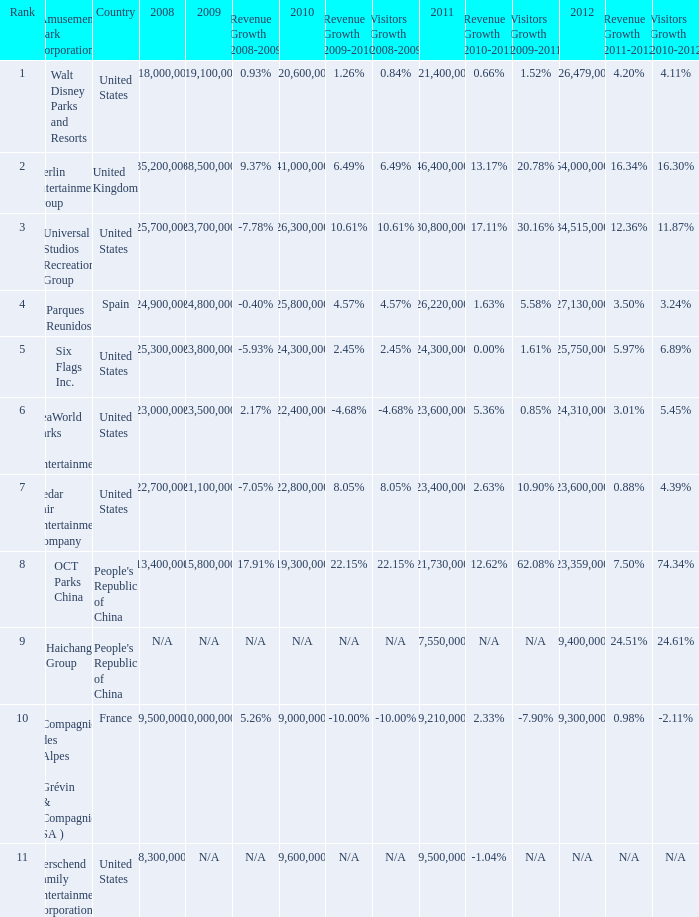In the United States the 2011 attendance at this amusement park corporation was larger than 30,800,000 but lists what as its 2008 attendance? 118000000.0. 